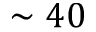Convert formula to latex. <formula><loc_0><loc_0><loc_500><loc_500>\sim 4 0</formula> 